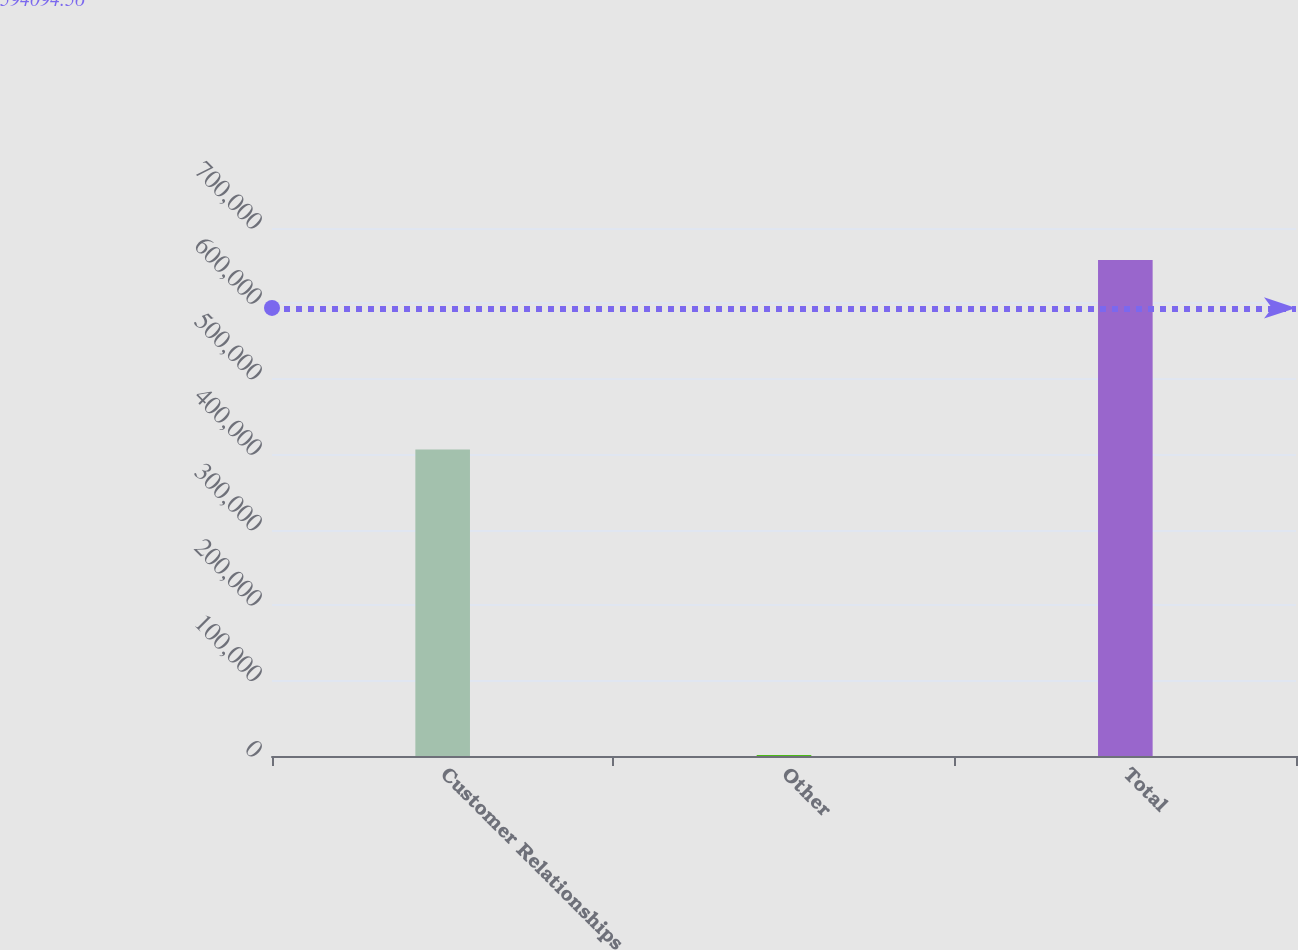Convert chart. <chart><loc_0><loc_0><loc_500><loc_500><bar_chart><fcel>Customer Relationships<fcel>Other<fcel>Total<nl><fcel>406386<fcel>1227<fcel>657601<nl></chart> 